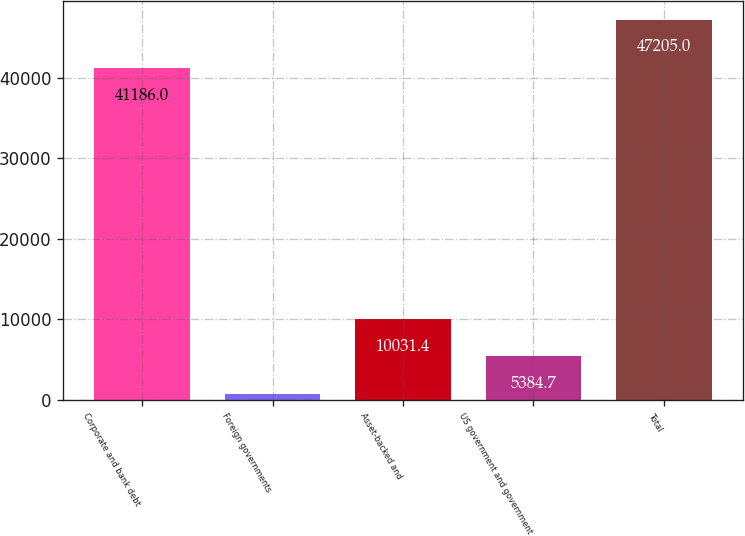Convert chart. <chart><loc_0><loc_0><loc_500><loc_500><bar_chart><fcel>Corporate and bank debt<fcel>Foreign governments<fcel>Asset-backed and<fcel>US government and government<fcel>Total<nl><fcel>41186<fcel>738<fcel>10031.4<fcel>5384.7<fcel>47205<nl></chart> 